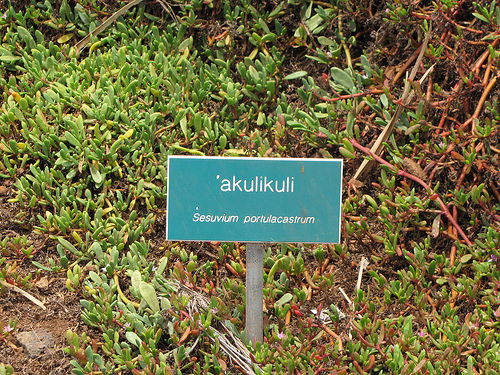<image>
Is the board in front of the bush? Yes. The board is positioned in front of the bush, appearing closer to the camera viewpoint. 